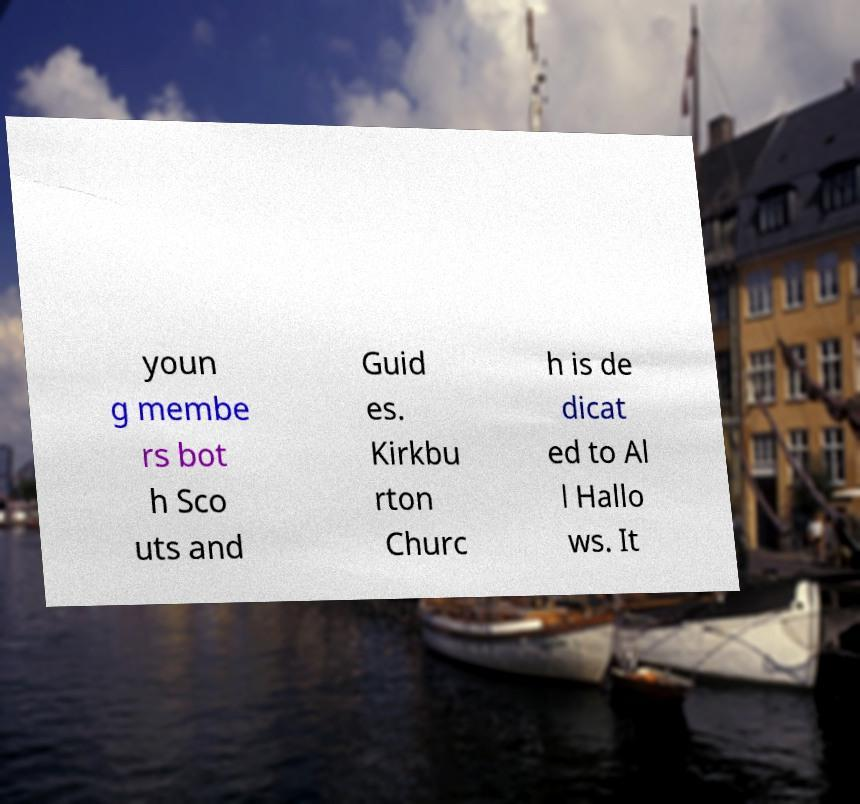Please read and relay the text visible in this image. What does it say? youn g membe rs bot h Sco uts and Guid es. Kirkbu rton Churc h is de dicat ed to Al l Hallo ws. It 